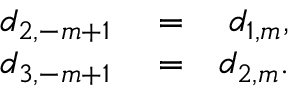Convert formula to latex. <formula><loc_0><loc_0><loc_500><loc_500>\begin{array} { r l r } { d _ { 2 , - m + 1 } } & = } & { d _ { 1 , m } , } \\ { d _ { 3 , - m + 1 } } & = } & { d _ { 2 , m } . } \end{array}</formula> 